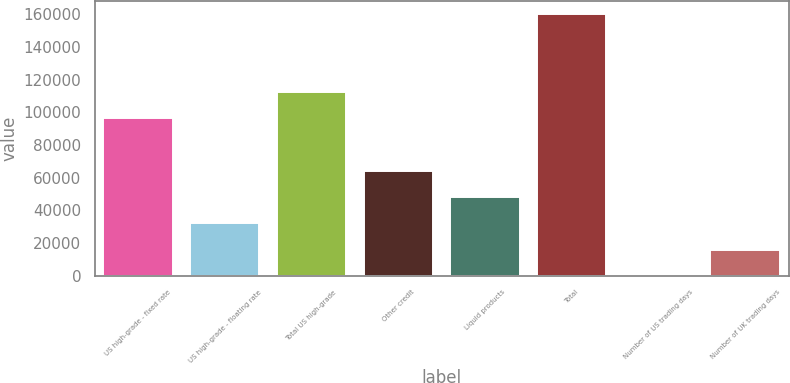Convert chart. <chart><loc_0><loc_0><loc_500><loc_500><bar_chart><fcel>US high-grade - fixed rate<fcel>US high-grade - floating rate<fcel>Total US high-grade<fcel>Other credit<fcel>Liquid products<fcel>Total<fcel>Number of US trading days<fcel>Number of UK trading days<nl><fcel>96736<fcel>32120<fcel>112766<fcel>64180<fcel>48150<fcel>160360<fcel>60<fcel>16090<nl></chart> 